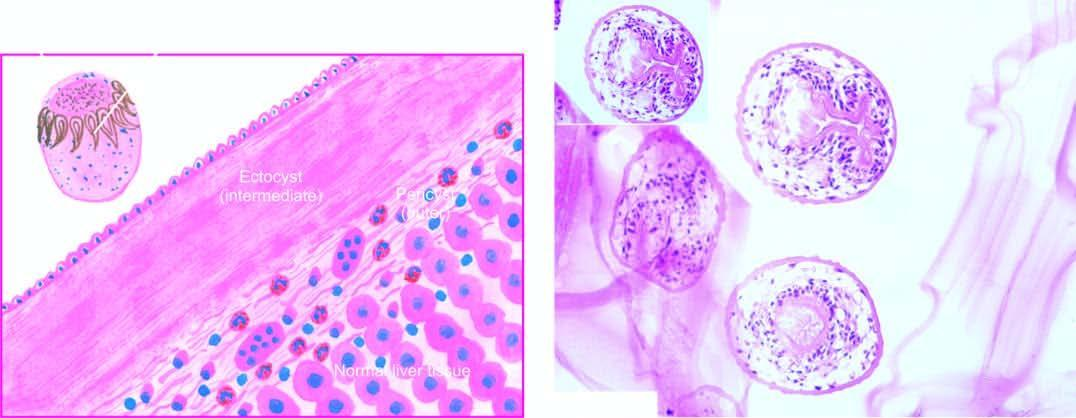does irregular nuclear show three layers in the wall of hydatid cyst?
Answer the question using a single word or phrase. No 